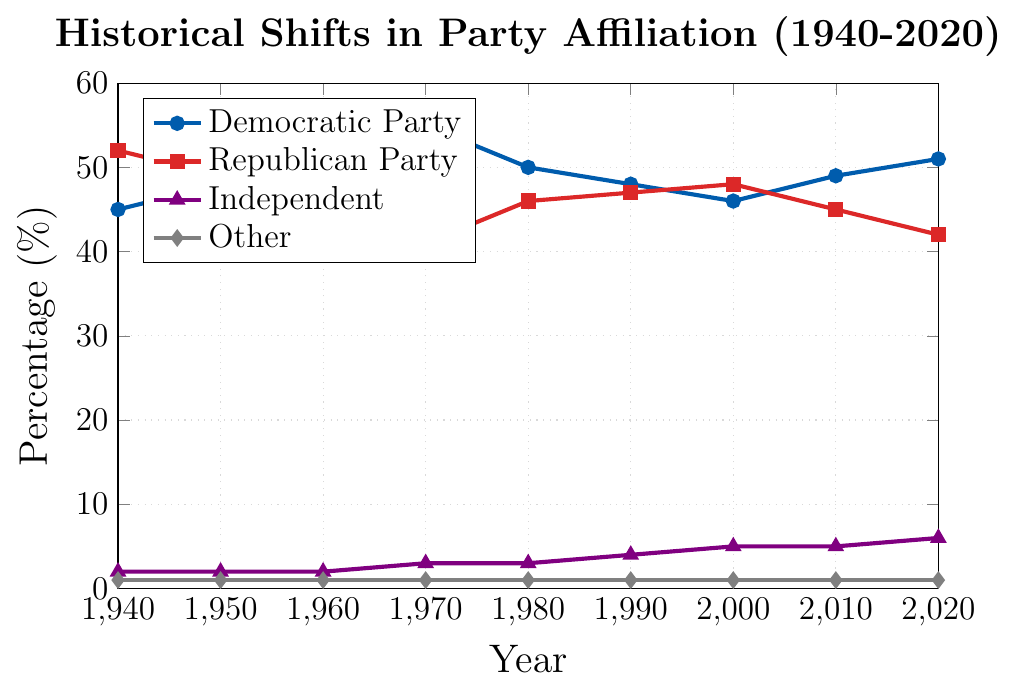What is the difference in the percentage of Democratic Party affiliation between 1970 and 1980? In 1970, the Democratic Party percentage is 55%. In 1980, it is 50%. The difference is calculated as 55% - 50% = 5%.
Answer: 5% Which party had a higher affiliation percentage in 1950, Democratic or Republican? In 1950, the Democratic Party had 48% affiliation, while the Republican Party had 49%. Therefore, the Republican Party had a higher affiliation percentage.
Answer: Republican Party What is the average percentage of Independent affiliation over the 80 years? Add the percentages of Independent affiliation from each decade and divide by the number of data points: (2% + 2% + 2% + 3% + 3% + 4% + 5% + 5% + 6%) / 9 = 3.56%.
Answer: 3.56% Which party had the largest decrease in affiliation percentage between two consecutive decades? To find the largest decrease, compare the differences between consecutive decades for each party. From 1970 to 1980, the Democratic Party decreased from 55% to 50%, which is a 5% decrease. This is the largest decrease among all parties in the data set between two consecutive decades.
Answer: Democratic Party What was the trend in the Republican Party affiliation from 1960 to 2020? In 1960, the Republican Party affiliation was 45%. It decreased to 41% in 1970, then increased to 46% in 1980, slightly increased to 47% in 1990, and further increased to 48% in 2000. However, it decreased to 45% in 2010 and further to 42% in 2020. The overall trend shows fluctuations with a slight decline over the complete period.
Answer: Fluctuating with a slight decline How did the percentage of voters identifying as 'Independent' change from 1970 to 2020? In 1970, the percentage of Independent voters was 3%. By 2020, it had increased to 6%. The change is an increase of 6% - 3% = 3%.
Answer: Increased by 3% What is the sum of the percentages for 'Other' affiliation across all decades? The percentage for 'Other' affiliation remains constant at 1% for each decade. Thus, the sum across all nine decades is 1% * 9 = 9%.
Answer: 9% In which decade did the Democratic Party have its peak affiliation percentage? The highest percentage for the Democratic Party is 55%, which occurred in 1970.
Answer: 1970 Compare the percentages of Independent affiliation in 1940 and 2020 and state the difference. The percentage of Independent affiliation in 1940 was 2%, and in 2020, it was 6%. The difference is 6% - 2% = 4%.
Answer: 4% Which party had the lowest affiliation in 1980, and what was the percentage? In 1980, the 'Other' party had the lowest affiliation percentage at 1%.
Answer: Other party at 1% 